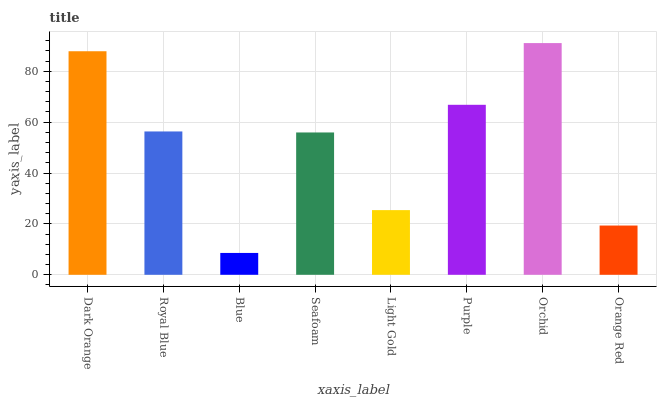Is Royal Blue the minimum?
Answer yes or no. No. Is Royal Blue the maximum?
Answer yes or no. No. Is Dark Orange greater than Royal Blue?
Answer yes or no. Yes. Is Royal Blue less than Dark Orange?
Answer yes or no. Yes. Is Royal Blue greater than Dark Orange?
Answer yes or no. No. Is Dark Orange less than Royal Blue?
Answer yes or no. No. Is Royal Blue the high median?
Answer yes or no. Yes. Is Seafoam the low median?
Answer yes or no. Yes. Is Purple the high median?
Answer yes or no. No. Is Dark Orange the low median?
Answer yes or no. No. 